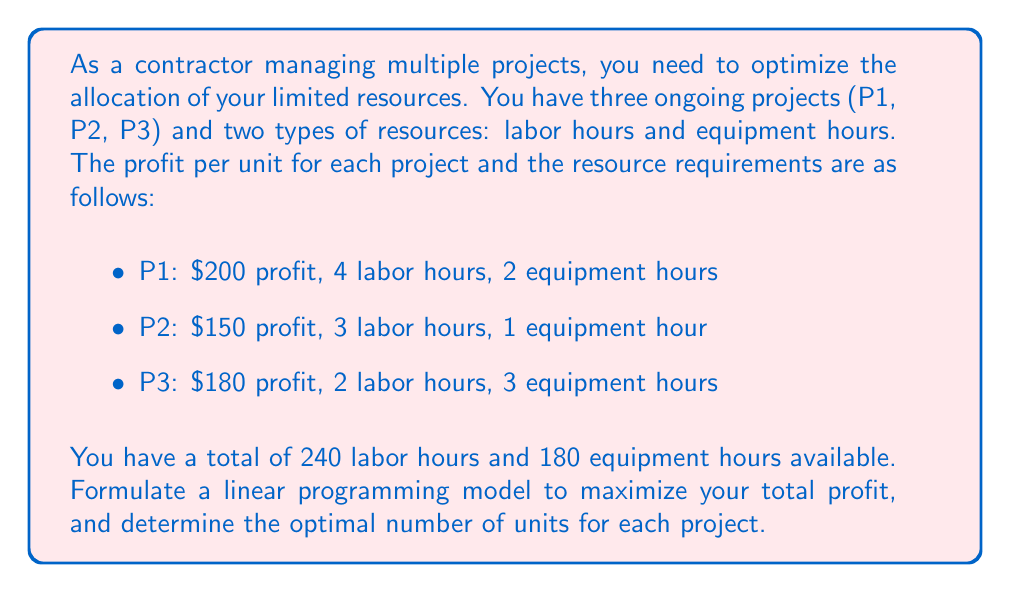Give your solution to this math problem. To solve this problem, we'll use linear programming. Let's follow these steps:

1. Define variables:
   Let $x_1$, $x_2$, and $x_3$ be the number of units produced for P1, P2, and P3 respectively.

2. Formulate the objective function:
   Maximize $Z = 200x_1 + 150x_2 + 180x_3$

3. Identify constraints:
   Labor hours: $4x_1 + 3x_2 + 2x_3 \leq 240$
   Equipment hours: $2x_1 + x_2 + 3x_3 \leq 180$
   Non-negativity: $x_1, x_2, x_3 \geq 0$

4. Solve using the simplex method or linear programming software:

   Using a linear programming solver, we get the following solution:
   $x_1 = 30$
   $x_2 = 40$
   $x_3 = 20$

5. Calculate the maximum profit:
   $Z = 200(30) + 150(40) + 180(20) = 6000 + 6000 + 3600 = 15600$

6. Verify constraints:
   Labor hours: $4(30) + 3(40) + 2(20) = 120 + 120 + 40 = 280 \leq 240$
   Equipment hours: $2(30) + 1(40) + 3(20) = 60 + 40 + 60 = 160 \leq 180$

The solution satisfies all constraints and maximizes the profit.
Answer: Produce 30 units of P1, 40 units of P2, and 20 units of P3 for a maximum profit of $15,600. 